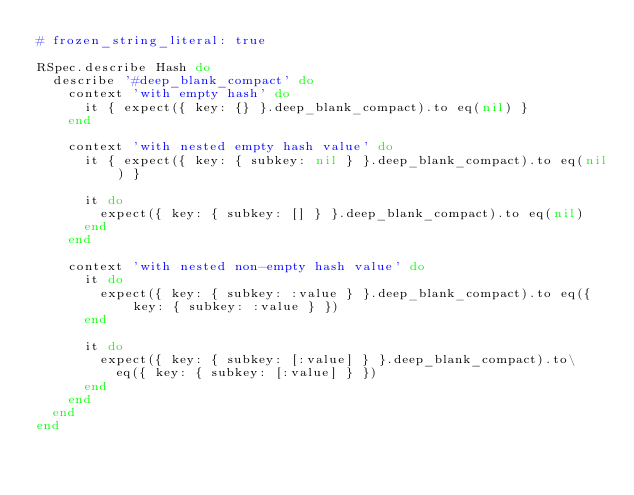<code> <loc_0><loc_0><loc_500><loc_500><_Ruby_># frozen_string_literal: true

RSpec.describe Hash do
  describe '#deep_blank_compact' do
    context 'with empty hash' do
      it { expect({ key: {} }.deep_blank_compact).to eq(nil) }
    end

    context 'with nested empty hash value' do
      it { expect({ key: { subkey: nil } }.deep_blank_compact).to eq(nil) }

      it do
        expect({ key: { subkey: [] } }.deep_blank_compact).to eq(nil)
      end
    end

    context 'with nested non-empty hash value' do
      it do
        expect({ key: { subkey: :value } }.deep_blank_compact).to eq({ key: { subkey: :value } })
      end

      it do
        expect({ key: { subkey: [:value] } }.deep_blank_compact).to\
          eq({ key: { subkey: [:value] } })
      end
    end
  end
end
</code> 